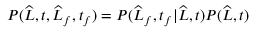<formula> <loc_0><loc_0><loc_500><loc_500>P ( \widehat { L } , t , \widehat { L } _ { f } , t _ { f } ) = P ( \widehat { L } _ { f } , t _ { f } | \widehat { L } , t ) P ( \widehat { L } , t )</formula> 